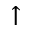Convert formula to latex. <formula><loc_0><loc_0><loc_500><loc_500>\uparrow</formula> 